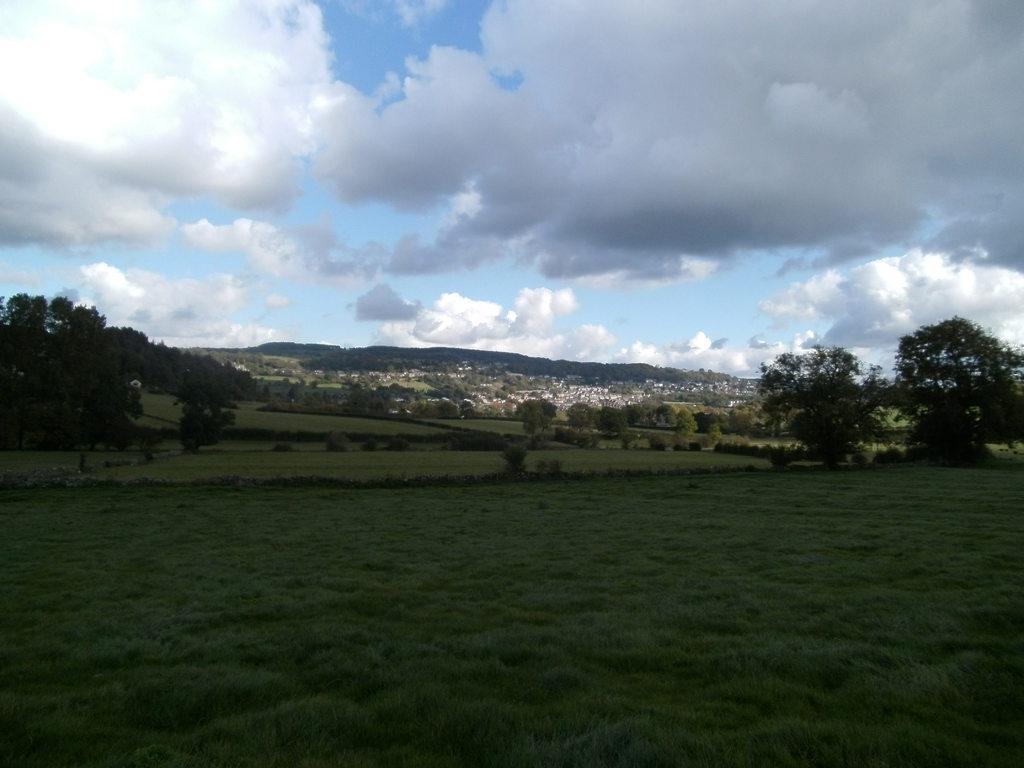Can you describe this image briefly? At the bottom of the image on the ground there is grass. In the background there are trees, buildings and hills. At the top of the image there is sky with clouds. 